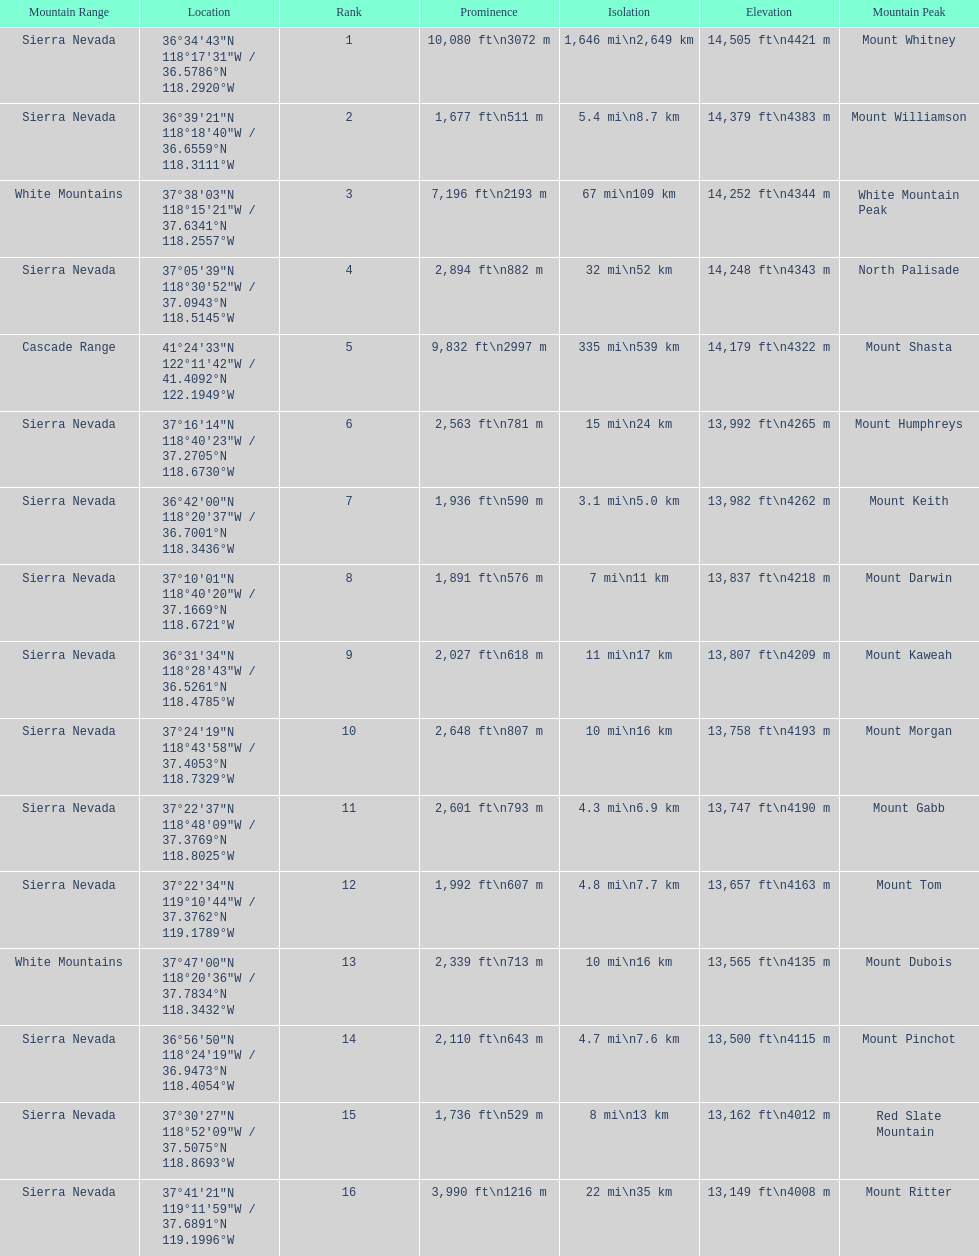In feet, what is the difference between the tallest peak and the 9th tallest peak in california? 698 ft. 